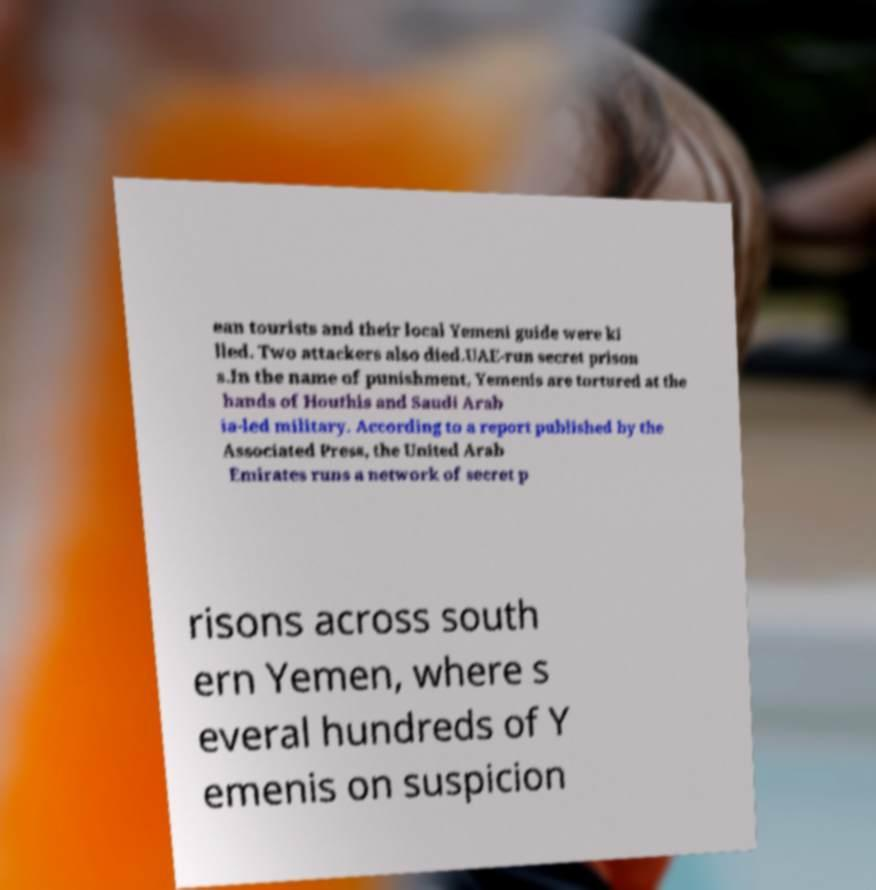There's text embedded in this image that I need extracted. Can you transcribe it verbatim? ean tourists and their local Yemeni guide were ki lled. Two attackers also died.UAE-run secret prison s.In the name of punishment, Yemenis are tortured at the hands of Houthis and Saudi Arab ia-led military. According to a report published by the Associated Press, the United Arab Emirates runs a network of secret p risons across south ern Yemen, where s everal hundreds of Y emenis on suspicion 